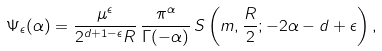<formula> <loc_0><loc_0><loc_500><loc_500>\Psi _ { \epsilon } ( \alpha ) = \frac { \mu ^ { \epsilon } } { 2 ^ { d + 1 - \epsilon } R } \, \frac { \pi ^ { \alpha } } { \Gamma ( - \alpha ) } \, S \left ( m , \frac { R } { 2 } ; - 2 \alpha - d + \epsilon \right ) ,</formula> 